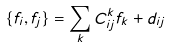Convert formula to latex. <formula><loc_0><loc_0><loc_500><loc_500>\{ f _ { i } , f _ { j } \} = \sum _ { k } C _ { i j } ^ { k } f _ { k } + d _ { i j }</formula> 